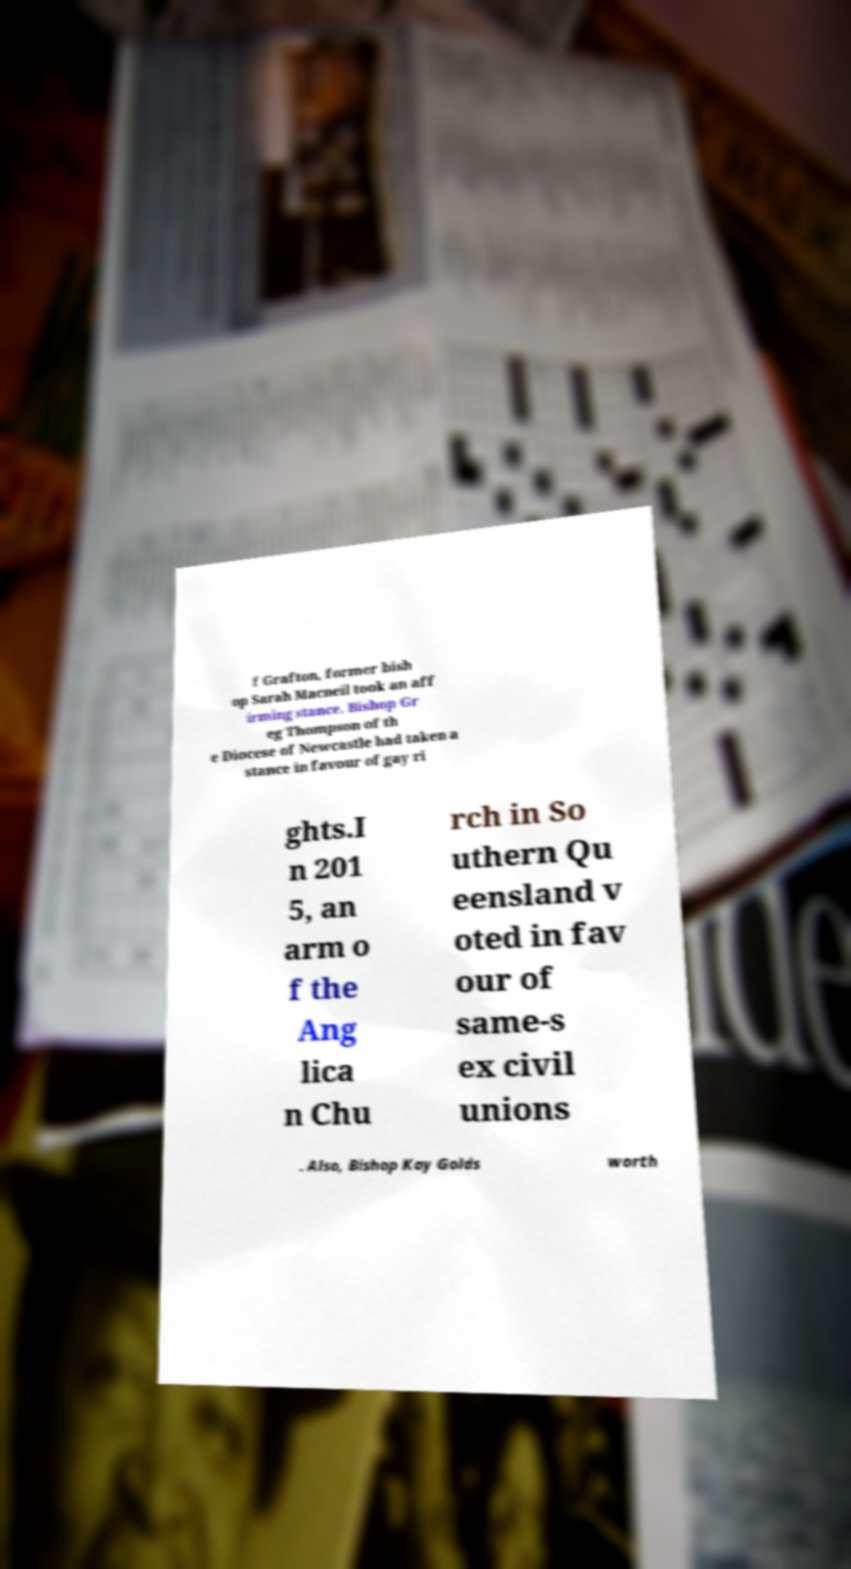Please identify and transcribe the text found in this image. f Grafton, former bish op Sarah Macneil took an aff irming stance. Bishop Gr eg Thompson of th e Diocese of Newcastle had taken a stance in favour of gay ri ghts.I n 201 5, an arm o f the Ang lica n Chu rch in So uthern Qu eensland v oted in fav our of same-s ex civil unions . Also, Bishop Kay Golds worth 